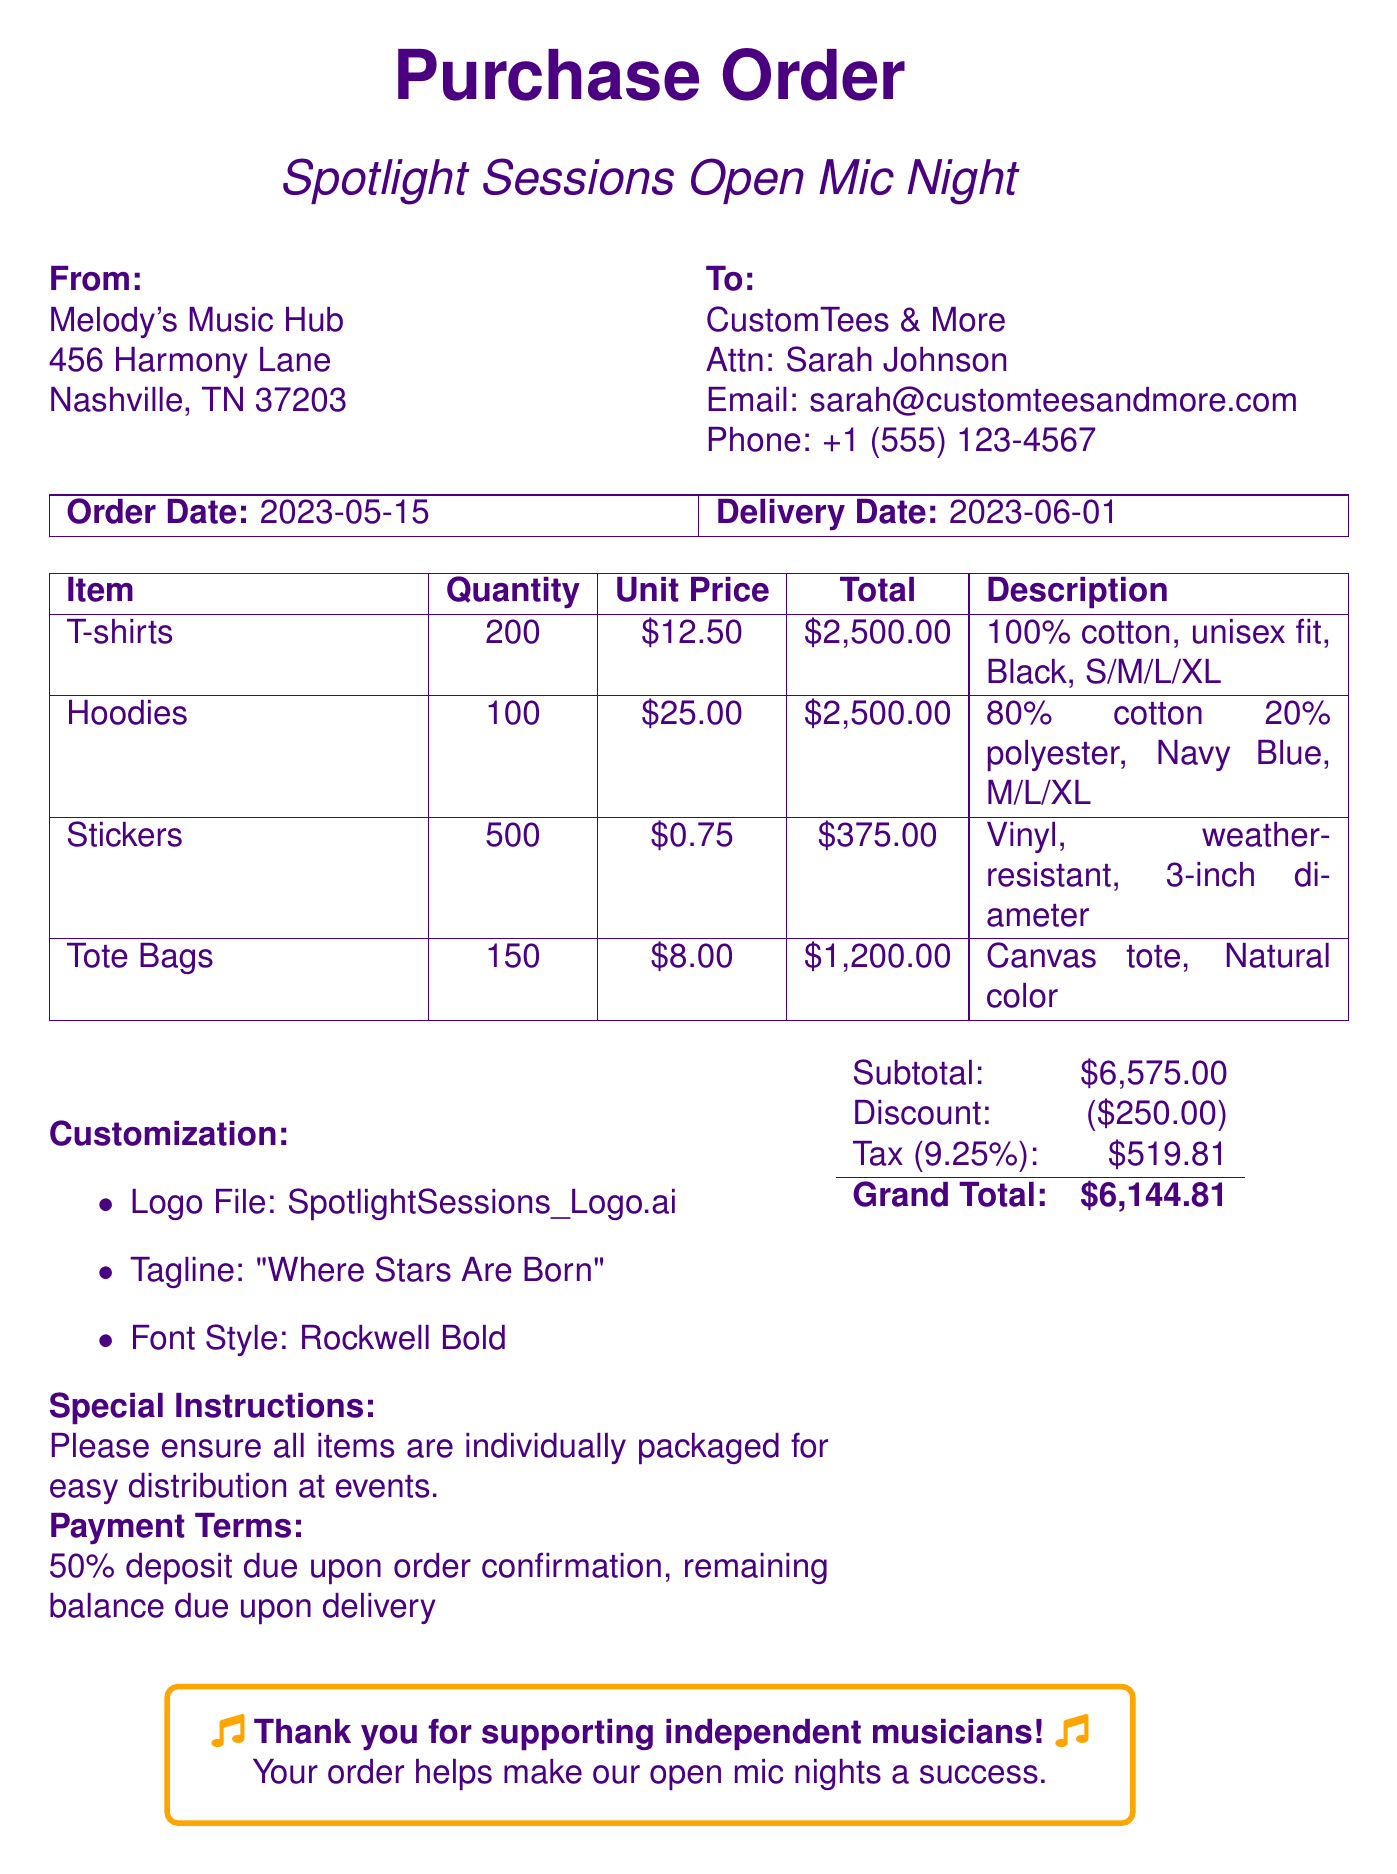What is the event name? The event name is specified at the beginning of the document as part of the transaction details.
Answer: Spotlight Sessions Open Mic Night Who is the organizer? The organizer's name is listed under the "From" section of the document.
Answer: Melody's Music Hub What is the total amount before discount? The total amount before discount is indicated just above the discount line in the financial summary.
Answer: $6,575.00 What are the sizes available for T-shirts? The available sizes for T-shirts are listed in the item description within the table.
Answer: S, M, L, XL What is the email address of the vendor contact? The email address of the vendor contact is provided in the "To" section.
Answer: sarah@customteesandmore.com How many stickers are ordered? The quantity of stickers ordered is clearly mentioned in the items table.
Answer: 500 What is the payment term? The payment term details are listed as part of the order conditions.
Answer: 50% deposit due upon order confirmation, remaining balance due upon delivery What is the discount provided? The type and amount of the discount is described in the financial summary section.
Answer: $250.00 When is the delivery date? The delivery date is specified in the order details section of the document.
Answer: 2023-06-01 